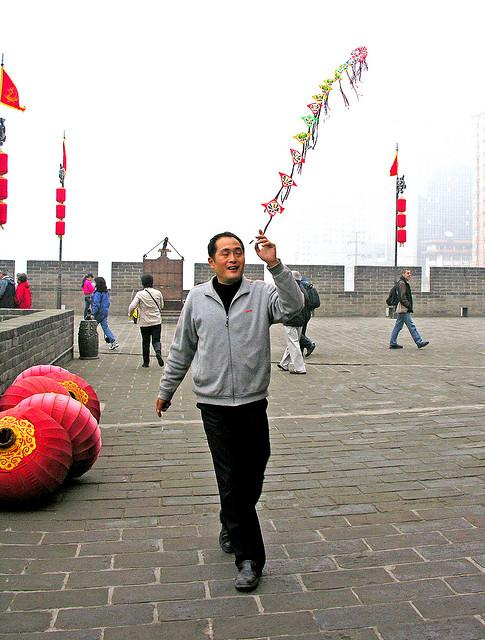The man closest to the right has what kind of pants on? jeans 